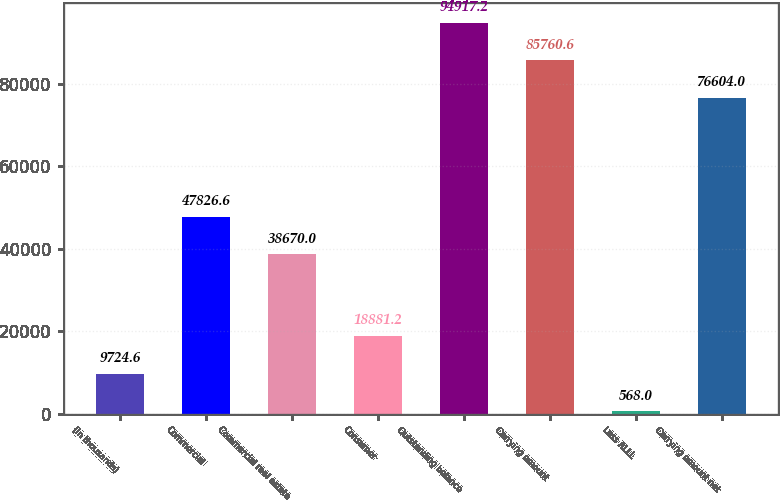Convert chart. <chart><loc_0><loc_0><loc_500><loc_500><bar_chart><fcel>(In thousands)<fcel>Commercial<fcel>Commercial real estate<fcel>Consumer<fcel>Outstanding balance<fcel>Carrying amount<fcel>Less ALLL<fcel>Carrying amount net<nl><fcel>9724.6<fcel>47826.6<fcel>38670<fcel>18881.2<fcel>94917.2<fcel>85760.6<fcel>568<fcel>76604<nl></chart> 